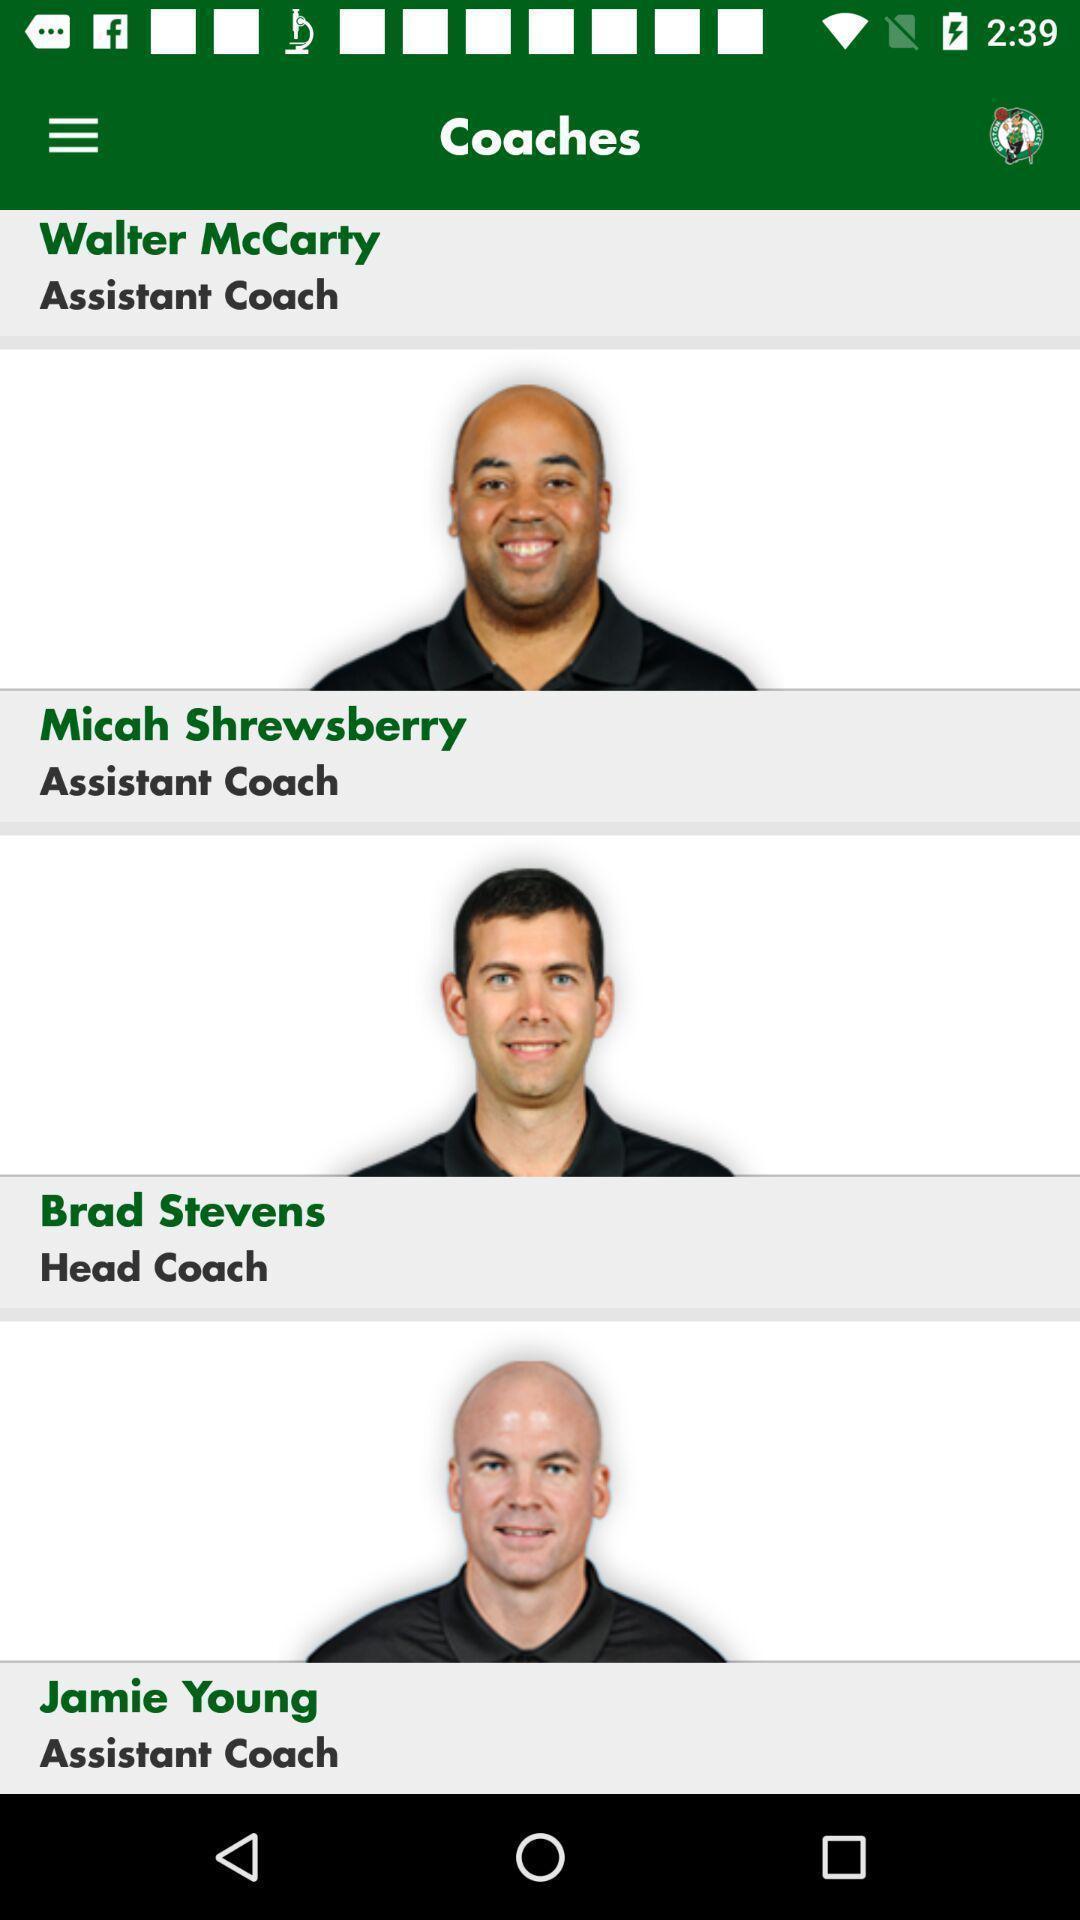Summarize the information in this screenshot. Screen displaying multiple users information and designation details. 